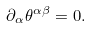<formula> <loc_0><loc_0><loc_500><loc_500>\partial _ { \alpha } \theta ^ { \alpha \beta } = 0 .</formula> 